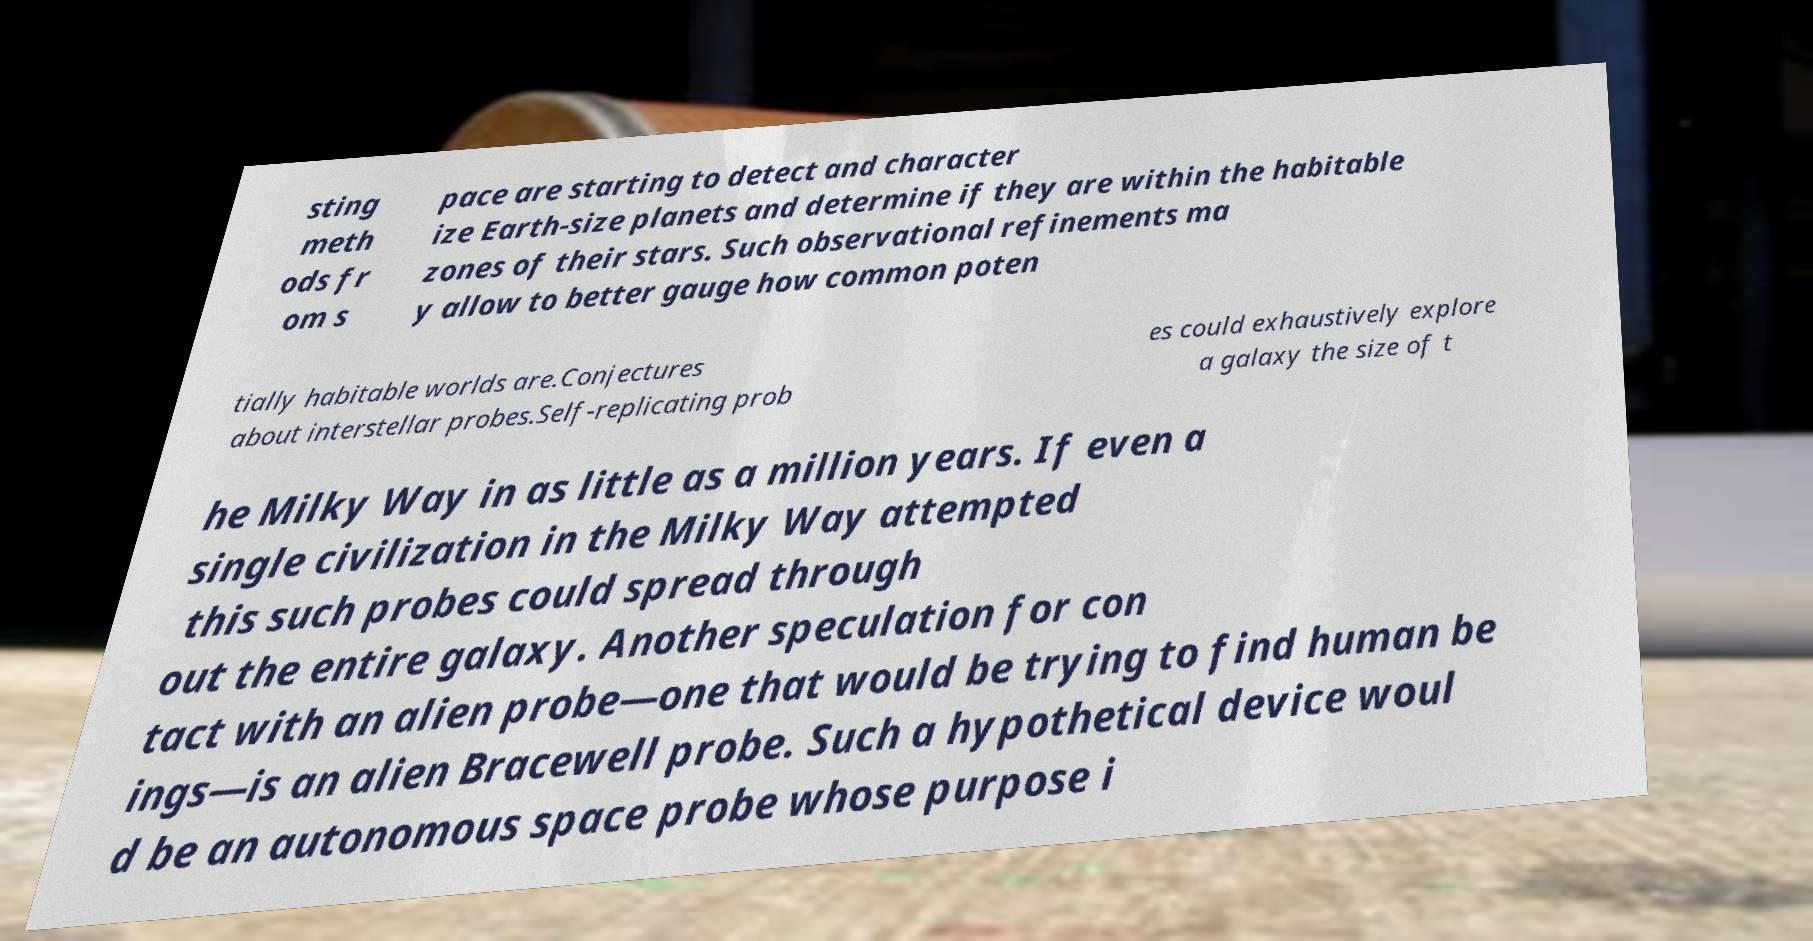There's text embedded in this image that I need extracted. Can you transcribe it verbatim? sting meth ods fr om s pace are starting to detect and character ize Earth-size planets and determine if they are within the habitable zones of their stars. Such observational refinements ma y allow to better gauge how common poten tially habitable worlds are.Conjectures about interstellar probes.Self-replicating prob es could exhaustively explore a galaxy the size of t he Milky Way in as little as a million years. If even a single civilization in the Milky Way attempted this such probes could spread through out the entire galaxy. Another speculation for con tact with an alien probe—one that would be trying to find human be ings—is an alien Bracewell probe. Such a hypothetical device woul d be an autonomous space probe whose purpose i 